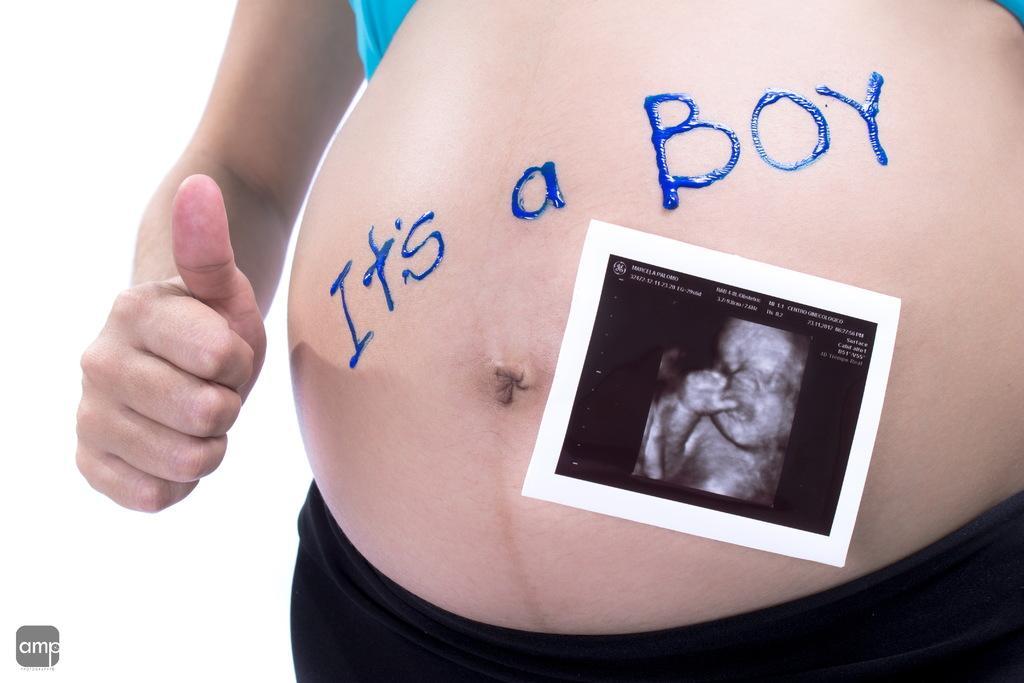Please provide a concise description of this image. In this image there is a photograph attached to the belly of a woman. There is some text on the belly. At the bottom of the image there is a logo. 